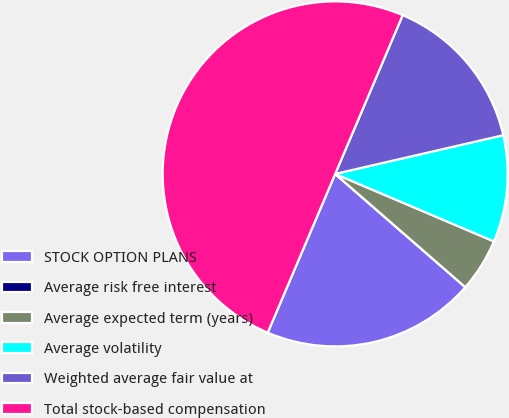<chart> <loc_0><loc_0><loc_500><loc_500><pie_chart><fcel>STOCK OPTION PLANS<fcel>Average risk free interest<fcel>Average expected term (years)<fcel>Average volatility<fcel>Weighted average fair value at<fcel>Total stock-based compensation<nl><fcel>20.0%<fcel>0.0%<fcel>5.0%<fcel>10.0%<fcel>15.0%<fcel>50.0%<nl></chart> 